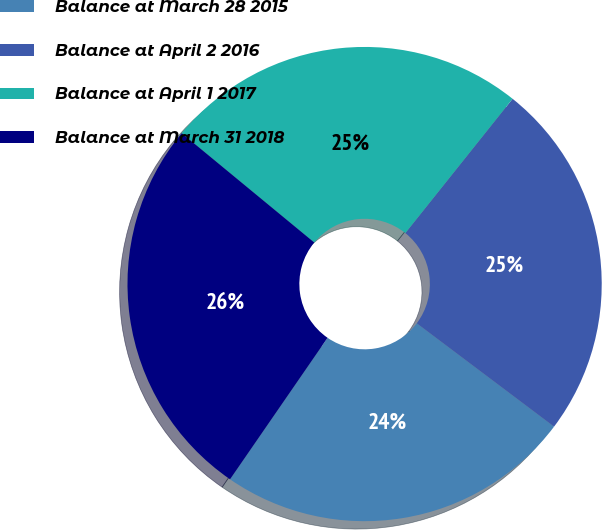<chart> <loc_0><loc_0><loc_500><loc_500><pie_chart><fcel>Balance at March 28 2015<fcel>Balance at April 2 2016<fcel>Balance at April 1 2017<fcel>Balance at March 31 2018<nl><fcel>24.34%<fcel>24.54%<fcel>24.75%<fcel>26.37%<nl></chart> 